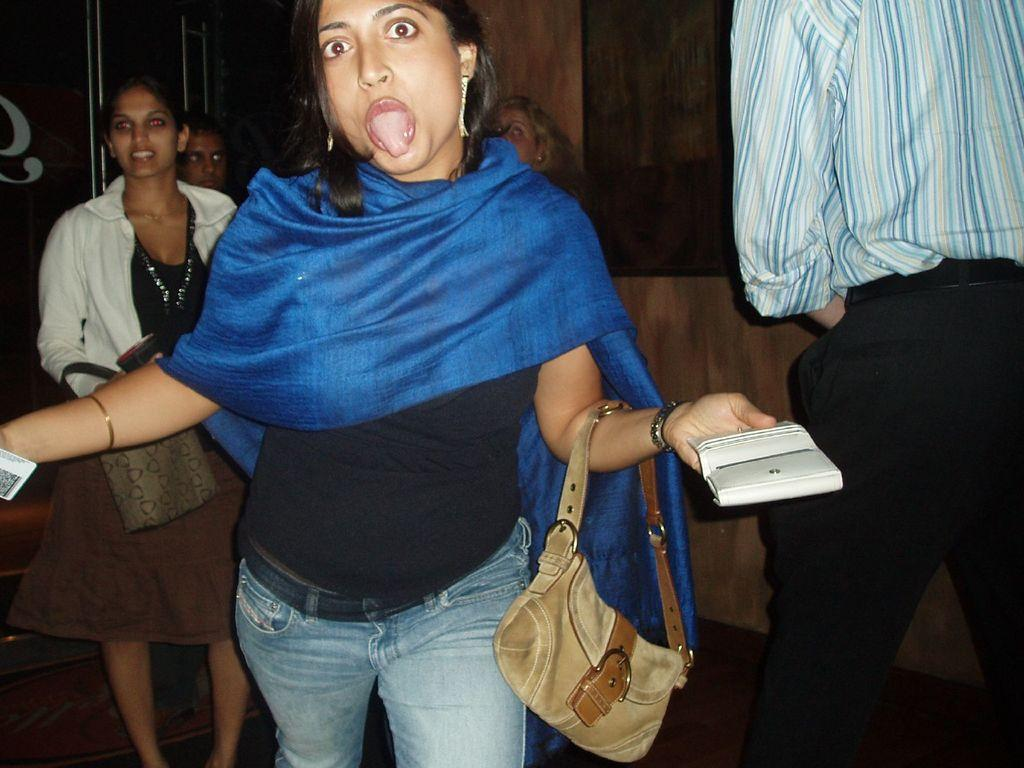How many people are in the image? There are persons standing in the image. What are the people holding in the image? One person is holding a bag and a wallet, while another person is holding a bag. What can be seen in the background of the image? There is a wall in the background of the image. What is visible beneath the people in the image? The ground is visible in the image. What type of corn is being taxed in the image? There is no corn or tax-related information present in the image. What degree does the person holding the bag have? There is no indication of a person's degree in the image. 